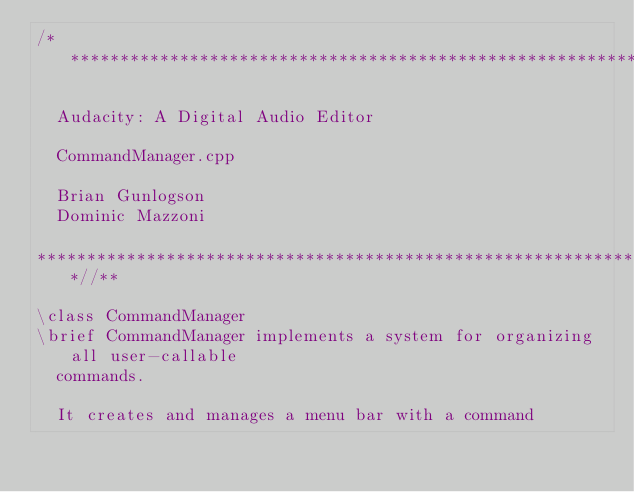Convert code to text. <code><loc_0><loc_0><loc_500><loc_500><_C++_>/**********************************************************************

  Audacity: A Digital Audio Editor

  CommandManager.cpp

  Brian Gunlogson
  Dominic Mazzoni

*******************************************************************//**

\class CommandManager
\brief CommandManager implements a system for organizing all user-callable
  commands.

  It creates and manages a menu bar with a command</code> 